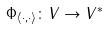Convert formula to latex. <formula><loc_0><loc_0><loc_500><loc_500>\Phi _ { \langle \cdot , \cdot \rangle } \colon V \rightarrow V ^ { * }</formula> 